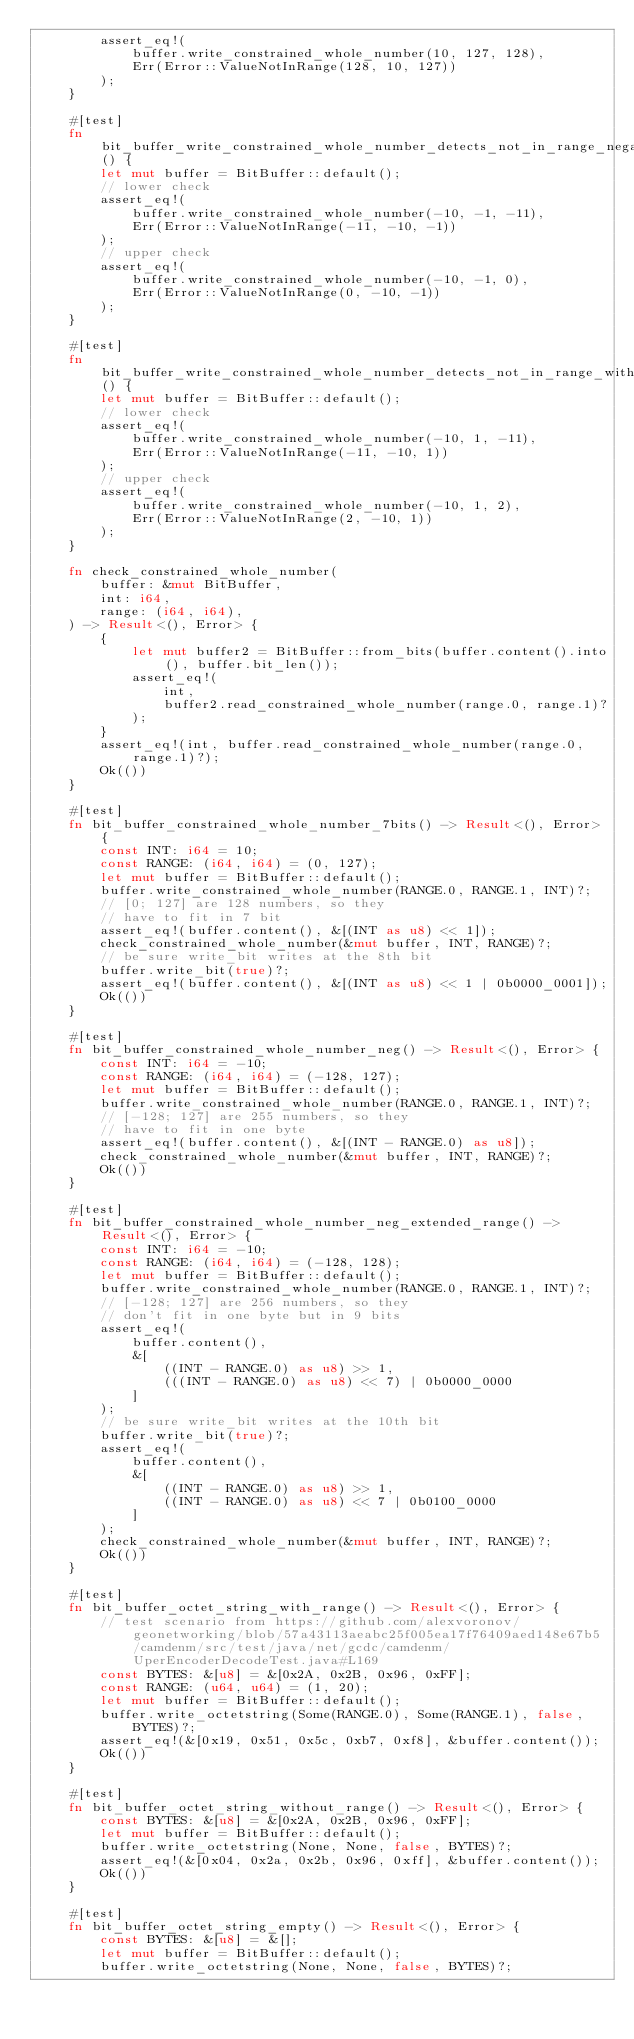Convert code to text. <code><loc_0><loc_0><loc_500><loc_500><_Rust_>        assert_eq!(
            buffer.write_constrained_whole_number(10, 127, 128),
            Err(Error::ValueNotInRange(128, 10, 127))
        );
    }

    #[test]
    fn bit_buffer_write_constrained_whole_number_detects_not_in_range_negative() {
        let mut buffer = BitBuffer::default();
        // lower check
        assert_eq!(
            buffer.write_constrained_whole_number(-10, -1, -11),
            Err(Error::ValueNotInRange(-11, -10, -1))
        );
        // upper check
        assert_eq!(
            buffer.write_constrained_whole_number(-10, -1, 0),
            Err(Error::ValueNotInRange(0, -10, -1))
        );
    }

    #[test]
    fn bit_buffer_write_constrained_whole_number_detects_not_in_range_with_negative() {
        let mut buffer = BitBuffer::default();
        // lower check
        assert_eq!(
            buffer.write_constrained_whole_number(-10, 1, -11),
            Err(Error::ValueNotInRange(-11, -10, 1))
        );
        // upper check
        assert_eq!(
            buffer.write_constrained_whole_number(-10, 1, 2),
            Err(Error::ValueNotInRange(2, -10, 1))
        );
    }

    fn check_constrained_whole_number(
        buffer: &mut BitBuffer,
        int: i64,
        range: (i64, i64),
    ) -> Result<(), Error> {
        {
            let mut buffer2 = BitBuffer::from_bits(buffer.content().into(), buffer.bit_len());
            assert_eq!(
                int,
                buffer2.read_constrained_whole_number(range.0, range.1)?
            );
        }
        assert_eq!(int, buffer.read_constrained_whole_number(range.0, range.1)?);
        Ok(())
    }

    #[test]
    fn bit_buffer_constrained_whole_number_7bits() -> Result<(), Error> {
        const INT: i64 = 10;
        const RANGE: (i64, i64) = (0, 127);
        let mut buffer = BitBuffer::default();
        buffer.write_constrained_whole_number(RANGE.0, RANGE.1, INT)?;
        // [0; 127] are 128 numbers, so they
        // have to fit in 7 bit
        assert_eq!(buffer.content(), &[(INT as u8) << 1]);
        check_constrained_whole_number(&mut buffer, INT, RANGE)?;
        // be sure write_bit writes at the 8th bit
        buffer.write_bit(true)?;
        assert_eq!(buffer.content(), &[(INT as u8) << 1 | 0b0000_0001]);
        Ok(())
    }

    #[test]
    fn bit_buffer_constrained_whole_number_neg() -> Result<(), Error> {
        const INT: i64 = -10;
        const RANGE: (i64, i64) = (-128, 127);
        let mut buffer = BitBuffer::default();
        buffer.write_constrained_whole_number(RANGE.0, RANGE.1, INT)?;
        // [-128; 127] are 255 numbers, so they
        // have to fit in one byte
        assert_eq!(buffer.content(), &[(INT - RANGE.0) as u8]);
        check_constrained_whole_number(&mut buffer, INT, RANGE)?;
        Ok(())
    }

    #[test]
    fn bit_buffer_constrained_whole_number_neg_extended_range() -> Result<(), Error> {
        const INT: i64 = -10;
        const RANGE: (i64, i64) = (-128, 128);
        let mut buffer = BitBuffer::default();
        buffer.write_constrained_whole_number(RANGE.0, RANGE.1, INT)?;
        // [-128; 127] are 256 numbers, so they
        // don't fit in one byte but in 9 bits
        assert_eq!(
            buffer.content(),
            &[
                ((INT - RANGE.0) as u8) >> 1,
                (((INT - RANGE.0) as u8) << 7) | 0b0000_0000
            ]
        );
        // be sure write_bit writes at the 10th bit
        buffer.write_bit(true)?;
        assert_eq!(
            buffer.content(),
            &[
                ((INT - RANGE.0) as u8) >> 1,
                ((INT - RANGE.0) as u8) << 7 | 0b0100_0000
            ]
        );
        check_constrained_whole_number(&mut buffer, INT, RANGE)?;
        Ok(())
    }

    #[test]
    fn bit_buffer_octet_string_with_range() -> Result<(), Error> {
        // test scenario from https://github.com/alexvoronov/geonetworking/blob/57a43113aeabc25f005ea17f76409aed148e67b5/camdenm/src/test/java/net/gcdc/camdenm/UperEncoderDecodeTest.java#L169
        const BYTES: &[u8] = &[0x2A, 0x2B, 0x96, 0xFF];
        const RANGE: (u64, u64) = (1, 20);
        let mut buffer = BitBuffer::default();
        buffer.write_octetstring(Some(RANGE.0), Some(RANGE.1), false, BYTES)?;
        assert_eq!(&[0x19, 0x51, 0x5c, 0xb7, 0xf8], &buffer.content());
        Ok(())
    }

    #[test]
    fn bit_buffer_octet_string_without_range() -> Result<(), Error> {
        const BYTES: &[u8] = &[0x2A, 0x2B, 0x96, 0xFF];
        let mut buffer = BitBuffer::default();
        buffer.write_octetstring(None, None, false, BYTES)?;
        assert_eq!(&[0x04, 0x2a, 0x2b, 0x96, 0xff], &buffer.content());
        Ok(())
    }

    #[test]
    fn bit_buffer_octet_string_empty() -> Result<(), Error> {
        const BYTES: &[u8] = &[];
        let mut buffer = BitBuffer::default();
        buffer.write_octetstring(None, None, false, BYTES)?;</code> 